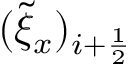Convert formula to latex. <formula><loc_0><loc_0><loc_500><loc_500>( \tilde { \xi } _ { x } ) _ { i + \frac { 1 } { 2 } }</formula> 